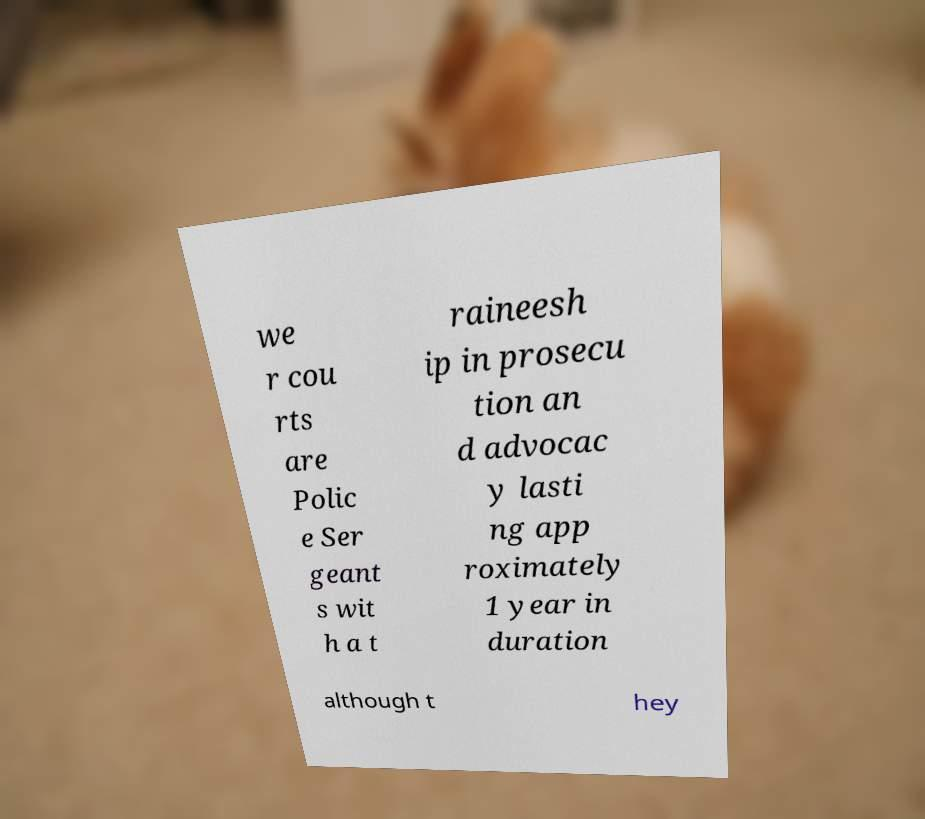Could you assist in decoding the text presented in this image and type it out clearly? we r cou rts are Polic e Ser geant s wit h a t raineesh ip in prosecu tion an d advocac y lasti ng app roximately 1 year in duration although t hey 